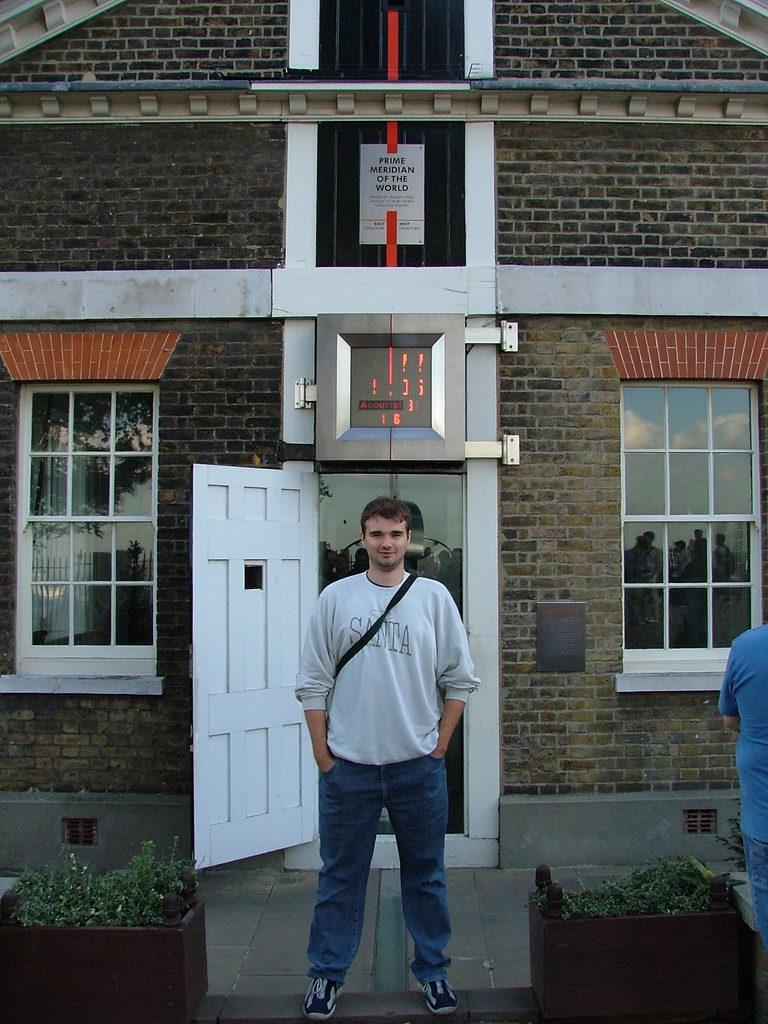<image>
Describe the image concisely. the man is wearing a tshirt saying Santa 